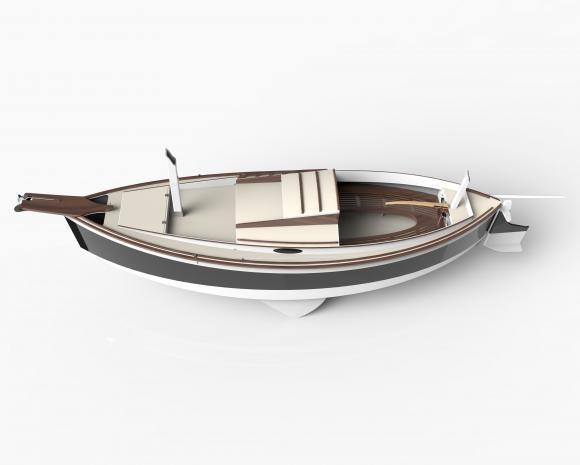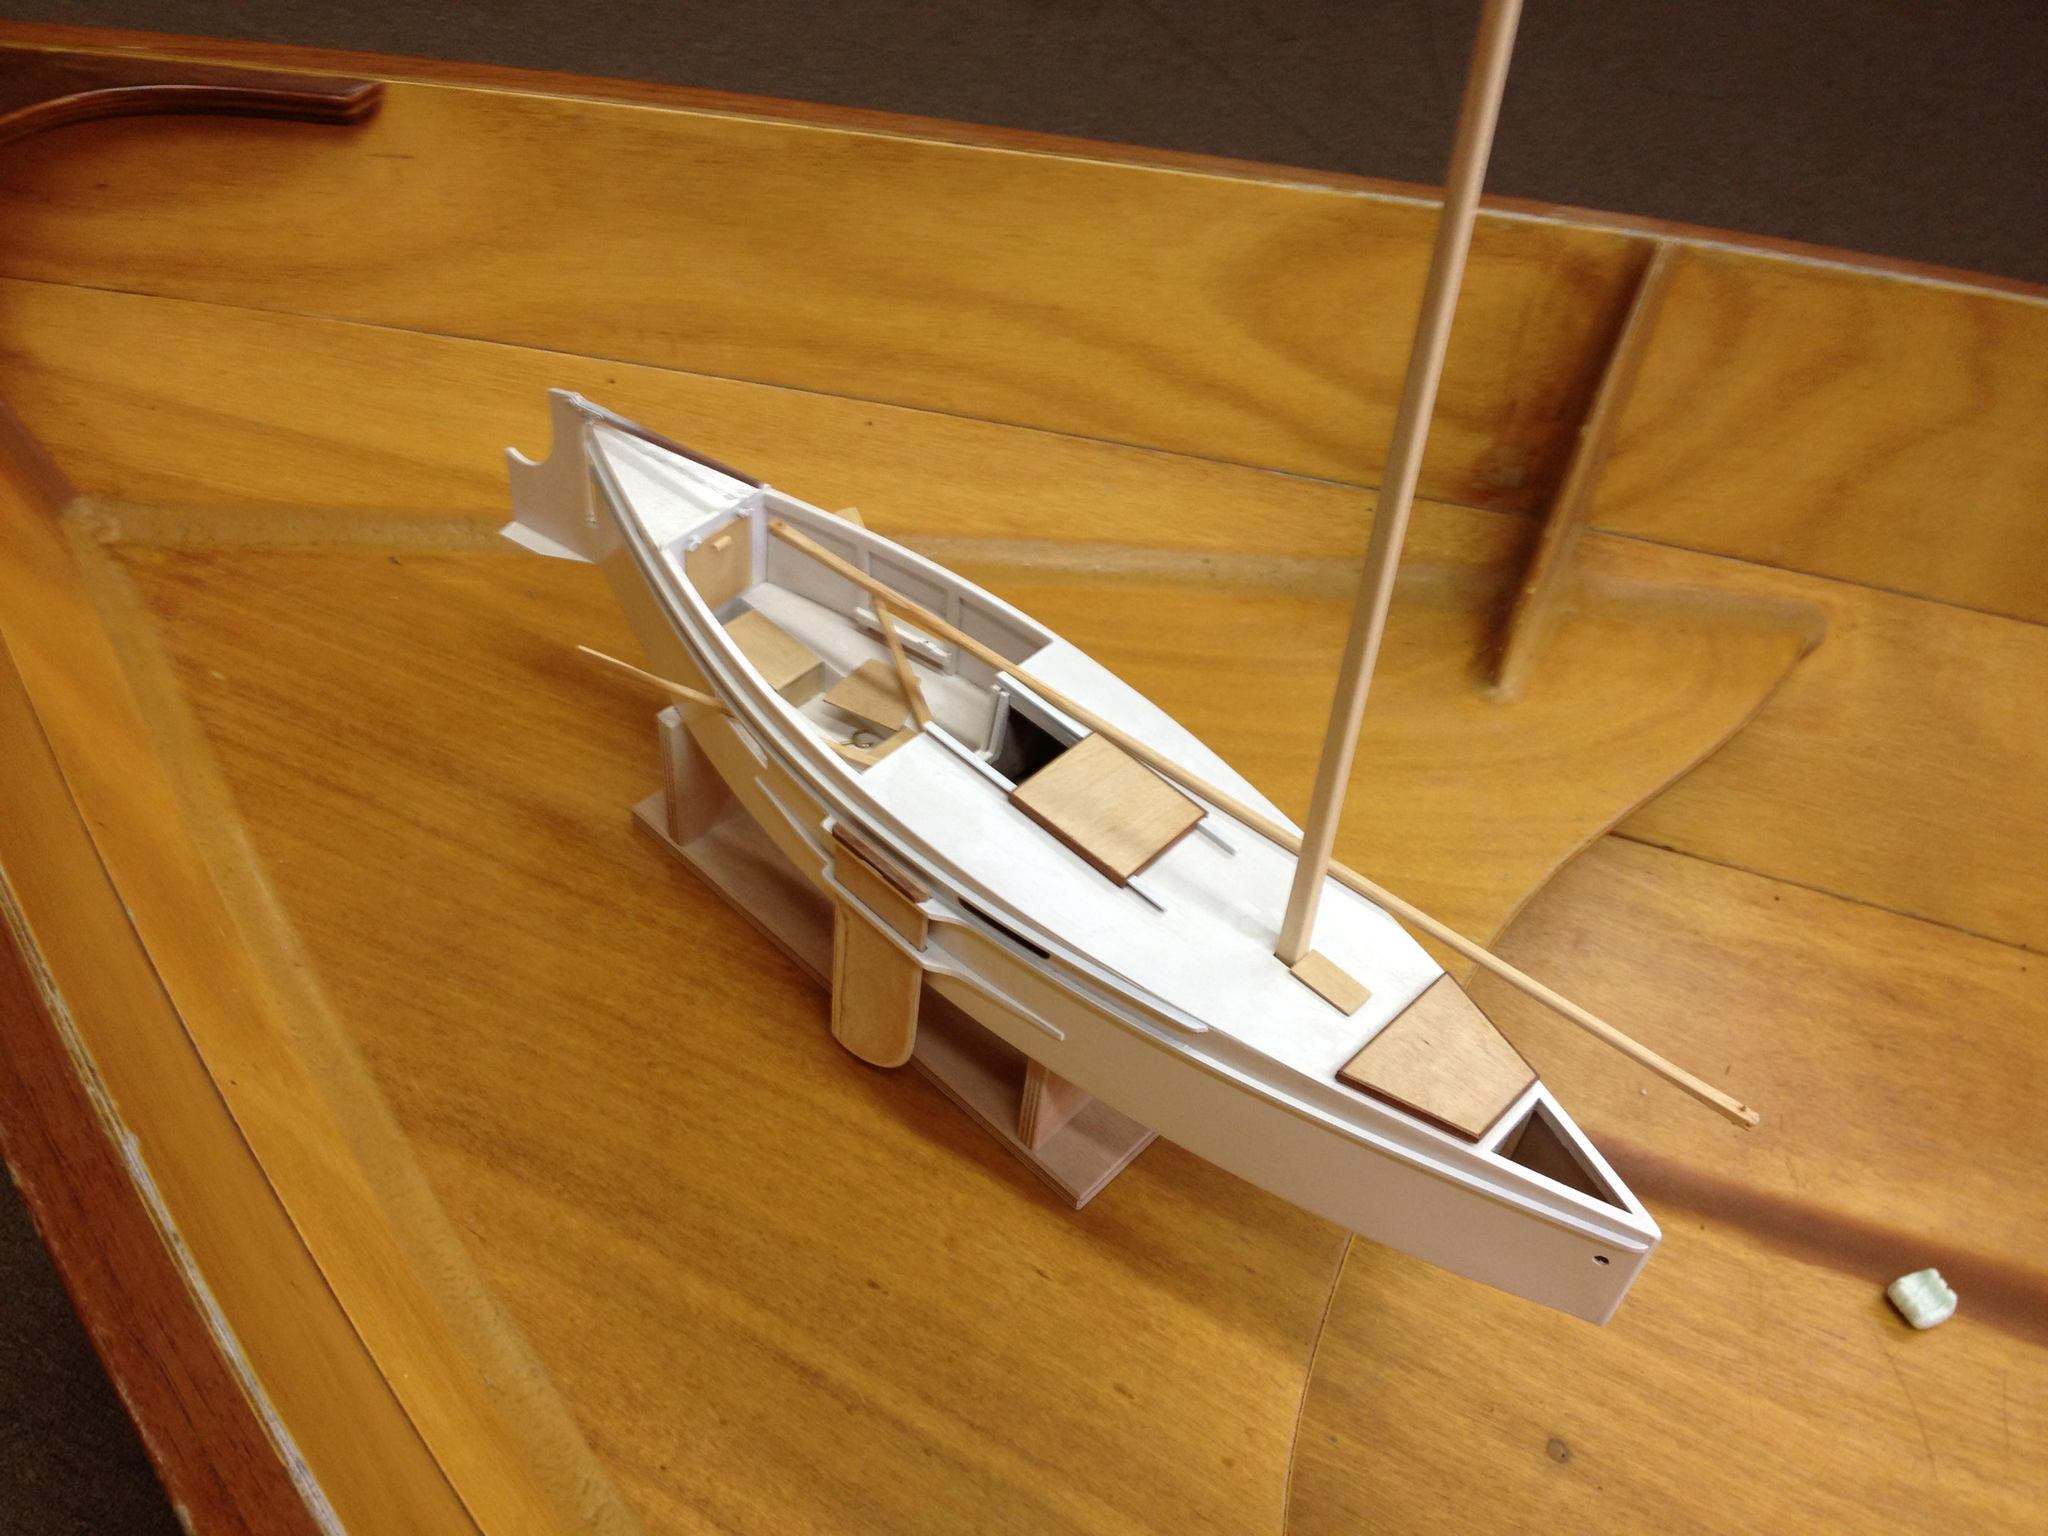The first image is the image on the left, the second image is the image on the right. Considering the images on both sides, is "The left and right images feature the same type of boat model, but the boat on the left has no upright dowel mast, and the boat on the right has an upright mast." valid? Answer yes or no. Yes. The first image is the image on the left, the second image is the image on the right. Examine the images to the left and right. Is the description "Both boats have unfurled sails." accurate? Answer yes or no. No. 